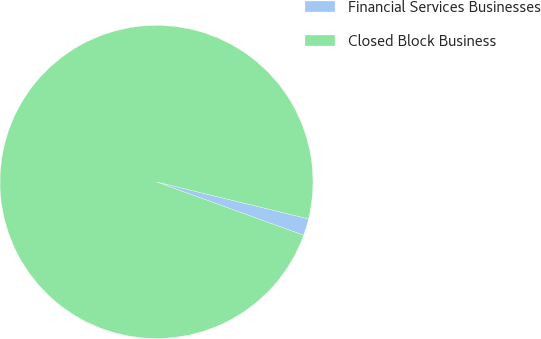Convert chart. <chart><loc_0><loc_0><loc_500><loc_500><pie_chart><fcel>Financial Services Businesses<fcel>Closed Block Business<nl><fcel>1.74%<fcel>98.26%<nl></chart> 